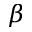Convert formula to latex. <formula><loc_0><loc_0><loc_500><loc_500>\beta</formula> 